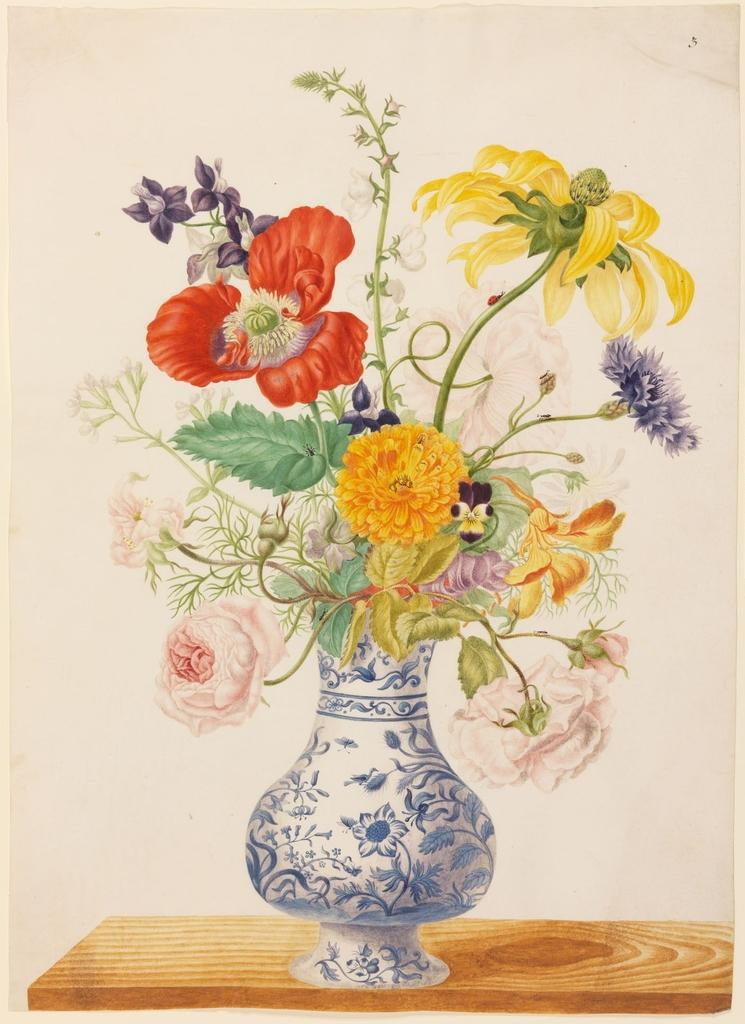What object is present in the image that typically holds flowers? There is a flower vase in the image. What color is the surface on which the flower vase is placed? The flower vase is on a brown surface. How would you describe the appearance of the flowers in the vase? The flowers in the vase are multicolored. What color is the wall visible in the background of the image? The wall in the background is white. What type of yoke is used to control the movement of the flowers in the image? There is no yoke present in the image, and the flowers are not being controlled or moved. 